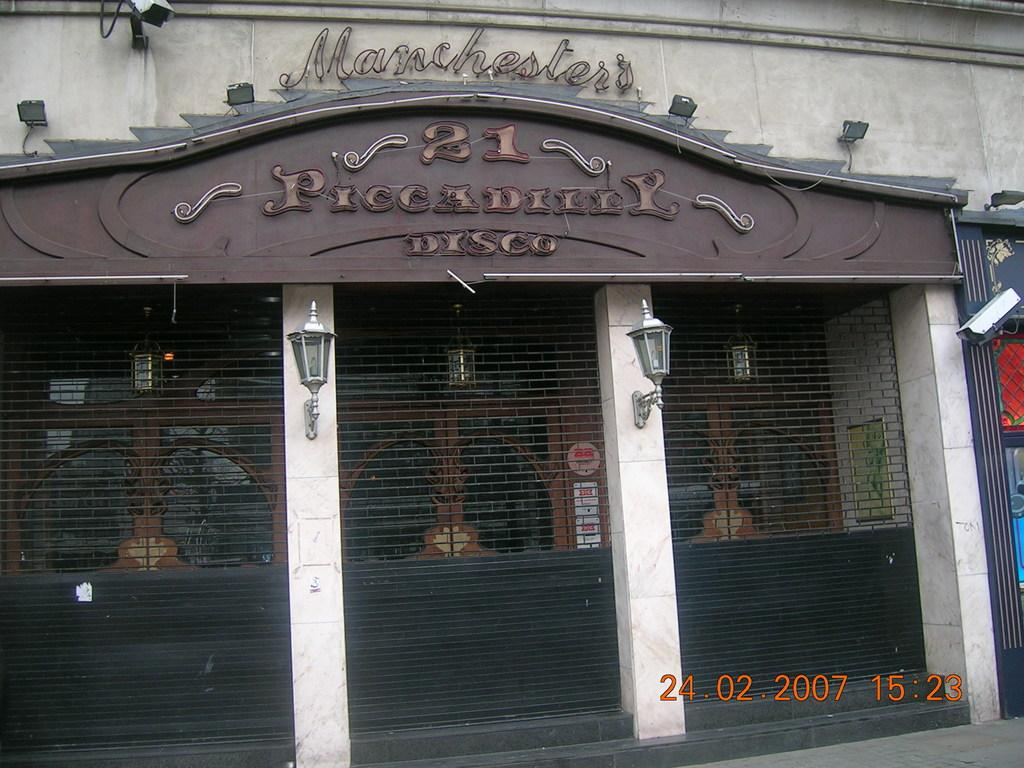What type of structure is visible in the image? There is a building in the image. What type of gates are present near the building? There are net gates in the image. What type of illumination can be seen in the image? There are lights in the image. What is written on the building? There is writing on the building. What type of memory does the building have in the image? The image does not provide information about the building's memory, as it is not a living being capable of having memories. 